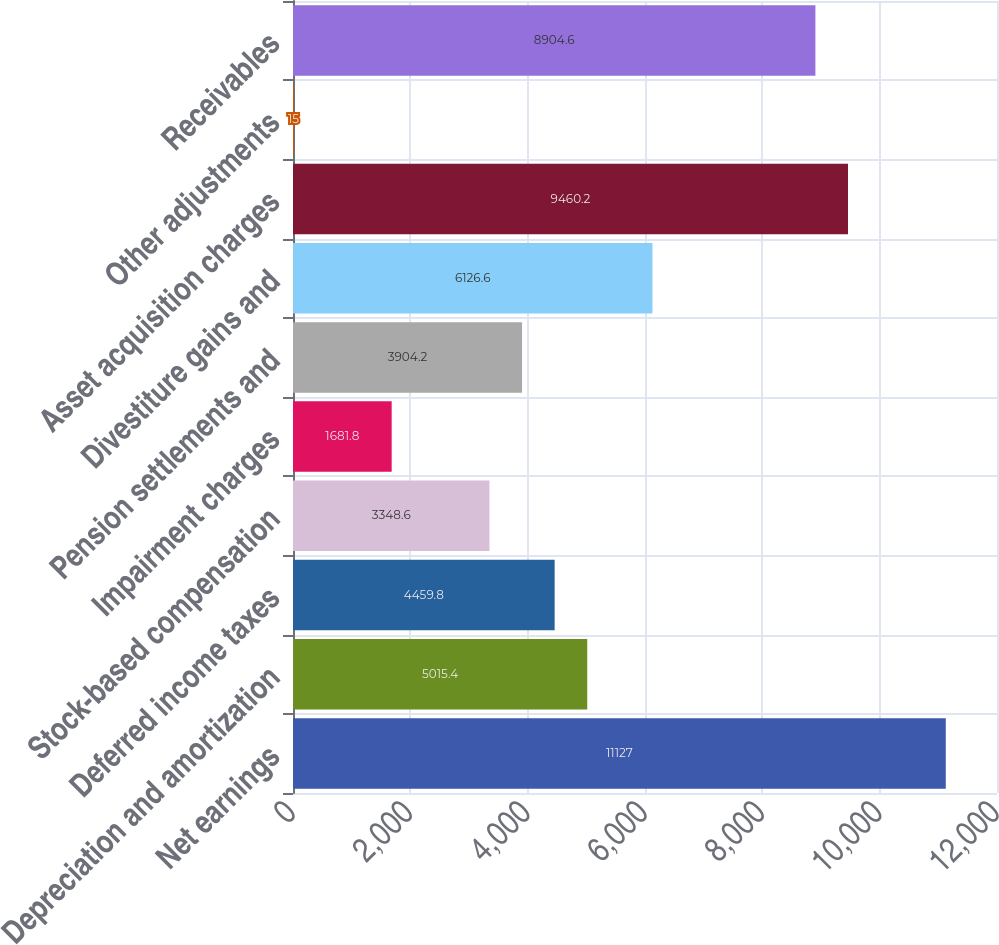Convert chart to OTSL. <chart><loc_0><loc_0><loc_500><loc_500><bar_chart><fcel>Net earnings<fcel>Depreciation and amortization<fcel>Deferred income taxes<fcel>Stock-based compensation<fcel>Impairment charges<fcel>Pension settlements and<fcel>Divestiture gains and<fcel>Asset acquisition charges<fcel>Other adjustments<fcel>Receivables<nl><fcel>11127<fcel>5015.4<fcel>4459.8<fcel>3348.6<fcel>1681.8<fcel>3904.2<fcel>6126.6<fcel>9460.2<fcel>15<fcel>8904.6<nl></chart> 